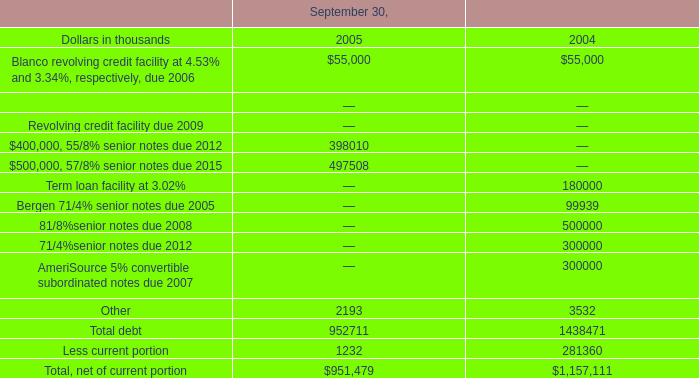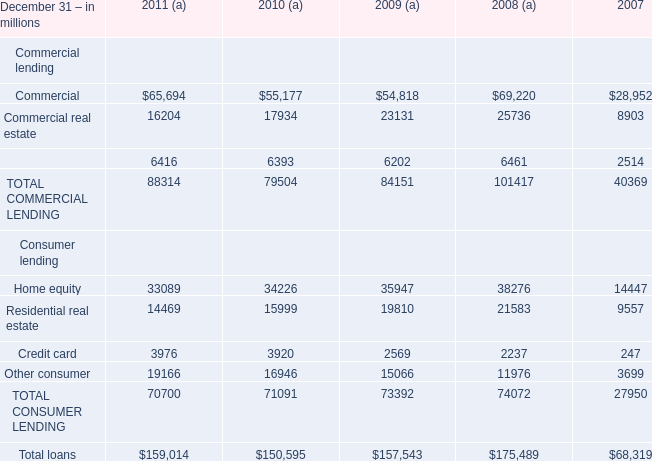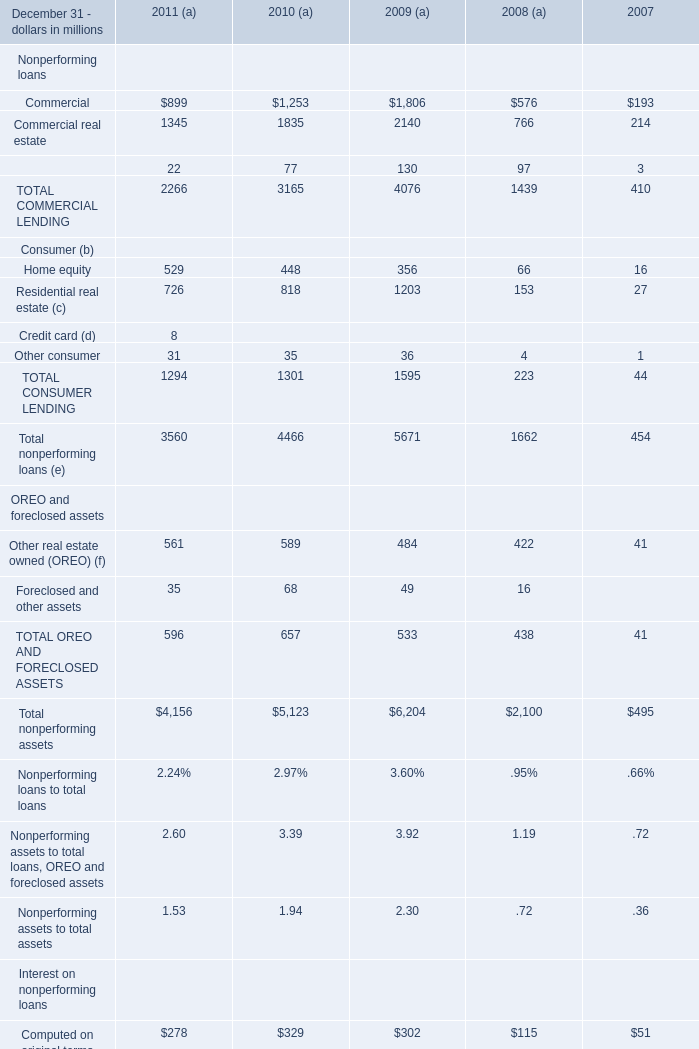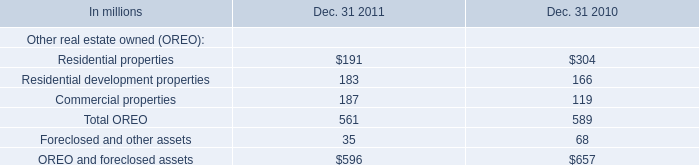What's the greatest value of Equipment lease financing in 2011 and 2010? (in million) 
Computations: (22 + 77)
Answer: 99.0. 